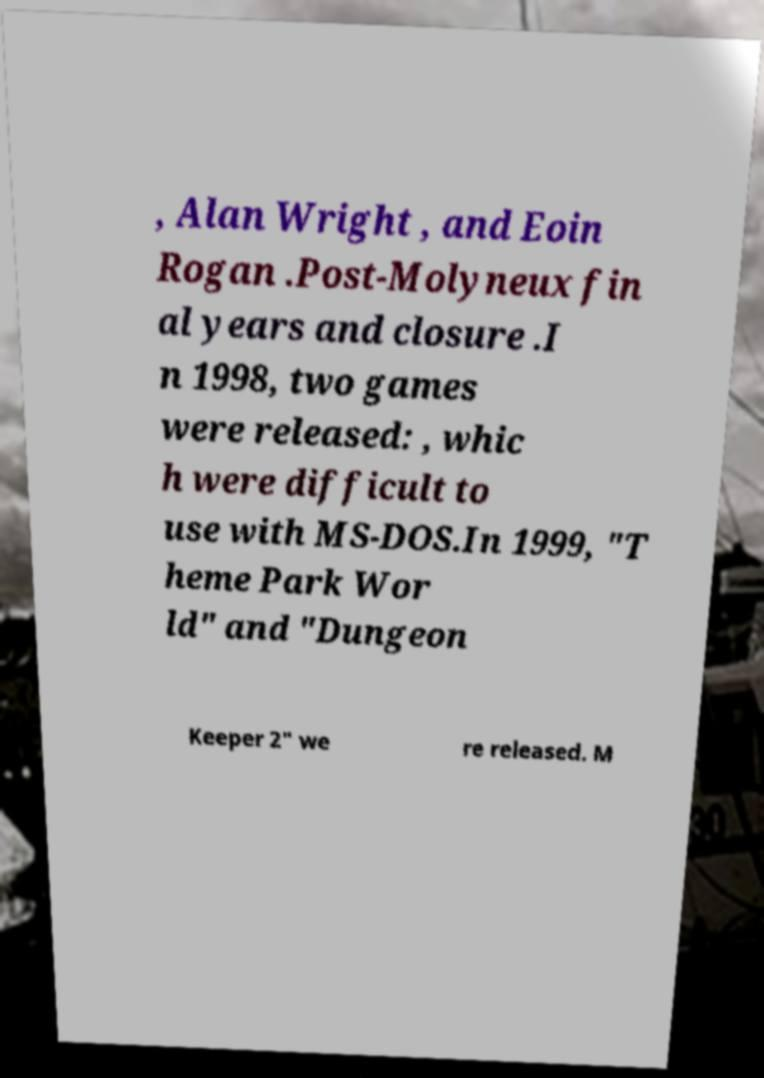I need the written content from this picture converted into text. Can you do that? , Alan Wright , and Eoin Rogan .Post-Molyneux fin al years and closure .I n 1998, two games were released: , whic h were difficult to use with MS-DOS.In 1999, "T heme Park Wor ld" and "Dungeon Keeper 2" we re released. M 